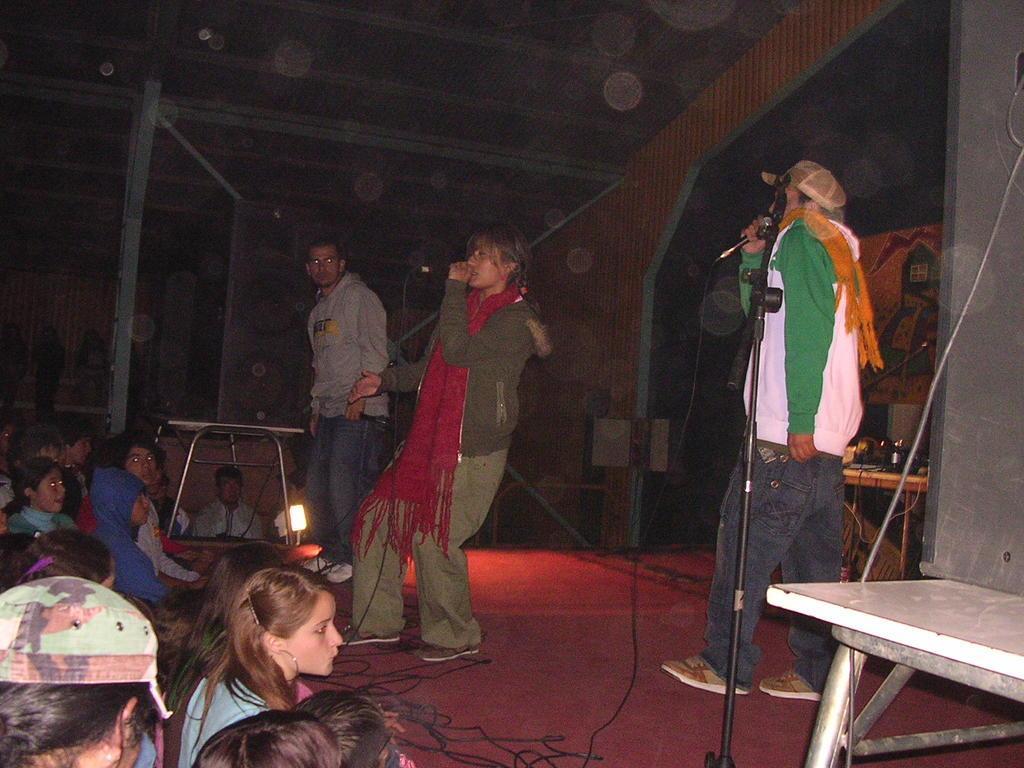Please provide a concise description of this image. In this picture we can see three persons are standing on the floor. They are holding a mike with their hands. This is table. Here we can see some persons are sitting on the floor. These are the cables and there is a light. 